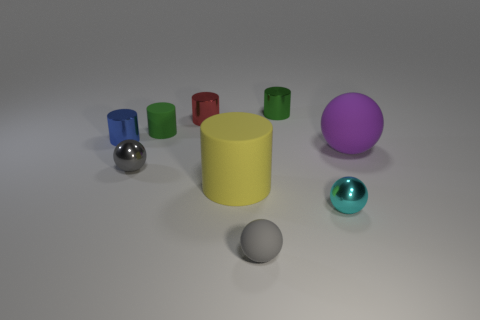What time of day does the lighting in this scene suggest? The lighting in this scene is evenly diffused without harsh shadows or highlights, which doesn't give away a specific time of day. It most likely simulates a neutral indoor lighting environment. 